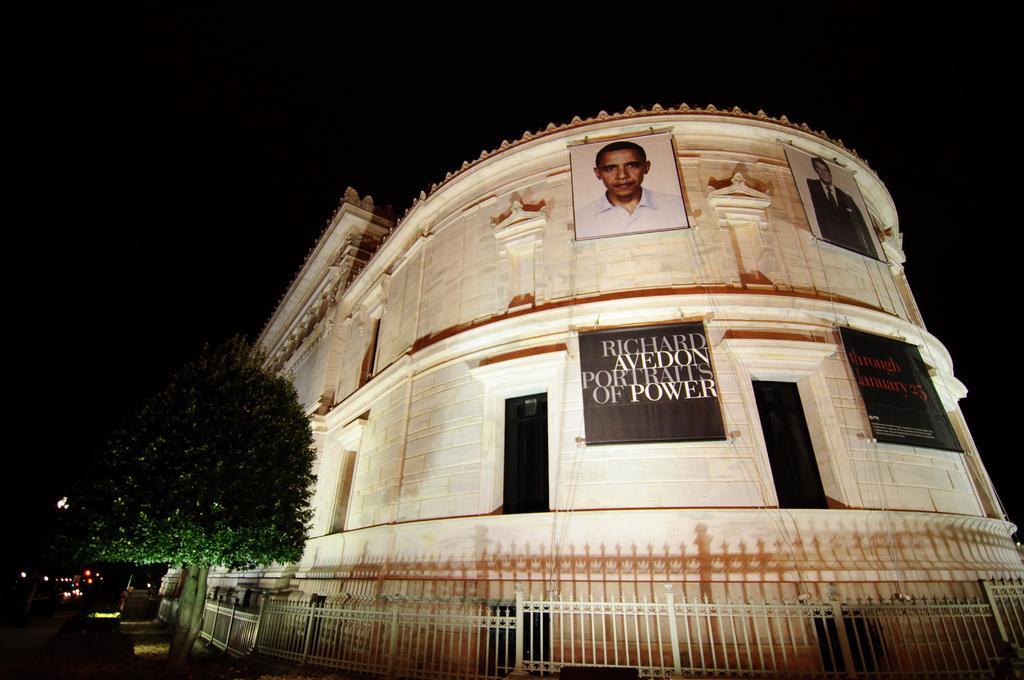Describe this image in one or two sentences. In this image I can see the building and few banners to the building. I can see few trees, fencing, lights and the black color background. 